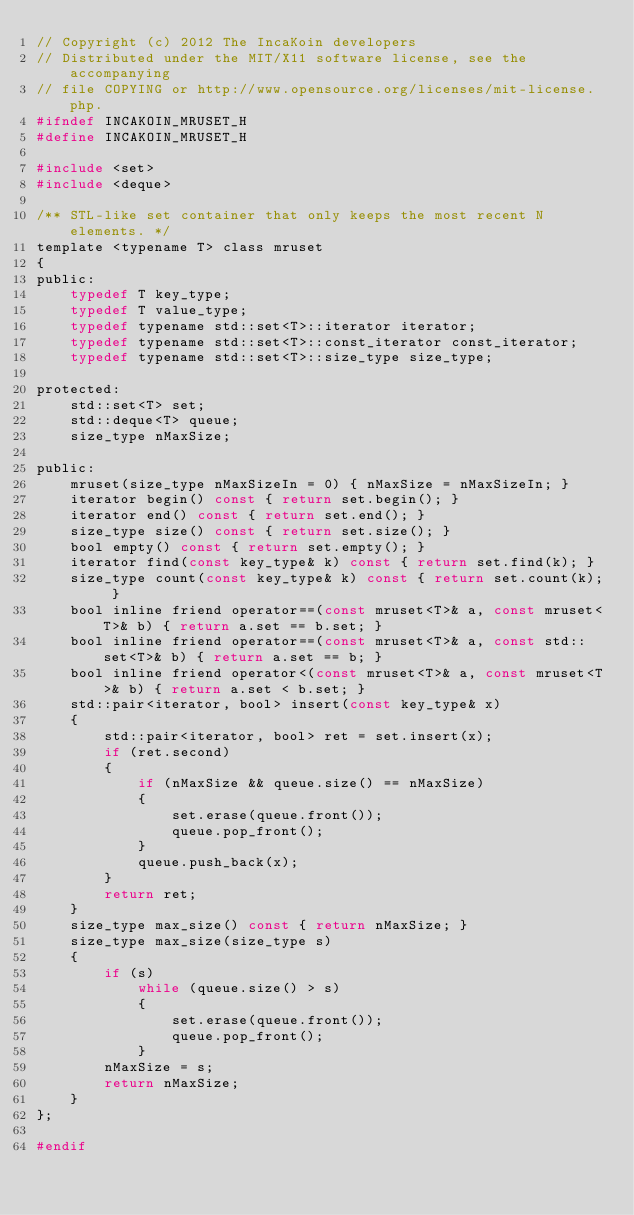Convert code to text. <code><loc_0><loc_0><loc_500><loc_500><_C_>// Copyright (c) 2012 The IncaKoin developers
// Distributed under the MIT/X11 software license, see the accompanying
// file COPYING or http://www.opensource.org/licenses/mit-license.php.
#ifndef INCAKOIN_MRUSET_H
#define INCAKOIN_MRUSET_H

#include <set>
#include <deque>

/** STL-like set container that only keeps the most recent N elements. */
template <typename T> class mruset
{
public:
    typedef T key_type;
    typedef T value_type;
    typedef typename std::set<T>::iterator iterator;
    typedef typename std::set<T>::const_iterator const_iterator;
    typedef typename std::set<T>::size_type size_type;

protected:
    std::set<T> set;
    std::deque<T> queue;
    size_type nMaxSize;

public:
    mruset(size_type nMaxSizeIn = 0) { nMaxSize = nMaxSizeIn; }
    iterator begin() const { return set.begin(); }
    iterator end() const { return set.end(); }
    size_type size() const { return set.size(); }
    bool empty() const { return set.empty(); }
    iterator find(const key_type& k) const { return set.find(k); }
    size_type count(const key_type& k) const { return set.count(k); }
    bool inline friend operator==(const mruset<T>& a, const mruset<T>& b) { return a.set == b.set; }
    bool inline friend operator==(const mruset<T>& a, const std::set<T>& b) { return a.set == b; }
    bool inline friend operator<(const mruset<T>& a, const mruset<T>& b) { return a.set < b.set; }
    std::pair<iterator, bool> insert(const key_type& x)
    {
        std::pair<iterator, bool> ret = set.insert(x);
        if (ret.second)
        {
            if (nMaxSize && queue.size() == nMaxSize)
            {
                set.erase(queue.front());
                queue.pop_front();
            }
            queue.push_back(x);
        }
        return ret;
    }
    size_type max_size() const { return nMaxSize; }
    size_type max_size(size_type s)
    {
        if (s)
            while (queue.size() > s)
            {
                set.erase(queue.front());
                queue.pop_front();
            }
        nMaxSize = s;
        return nMaxSize;
    }
};

#endif
</code> 